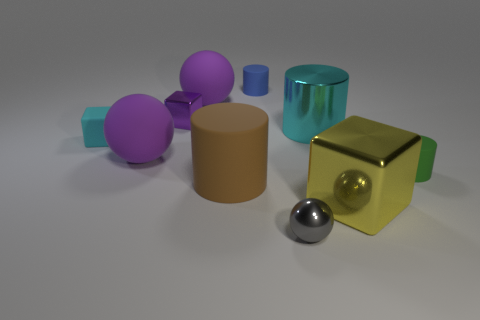Is the number of small purple balls less than the number of tiny purple shiny objects?
Ensure brevity in your answer.  Yes. Does the cyan thing on the left side of the small gray thing have the same material as the sphere behind the cyan cylinder?
Provide a short and direct response. Yes. Is the number of tiny blue rubber cylinders that are in front of the small blue rubber object less than the number of large metal things?
Give a very brief answer. Yes. There is a small metal object on the left side of the gray metal ball; what number of small blue rubber cylinders are on the left side of it?
Your answer should be very brief. 0. There is a object that is left of the large yellow block and in front of the brown rubber cylinder; how big is it?
Your answer should be compact. Small. Is there any other thing that has the same material as the big yellow thing?
Give a very brief answer. Yes. Is the material of the green thing the same as the cyan object right of the purple metallic block?
Your response must be concise. No. Is the number of cyan matte cubes behind the small purple cube less than the number of big purple objects that are on the right side of the cyan cylinder?
Offer a very short reply. No. What is the material of the yellow block to the right of the tiny metal ball?
Offer a very short reply. Metal. What color is the tiny thing that is both behind the tiny cyan object and to the left of the big brown cylinder?
Ensure brevity in your answer.  Purple. 